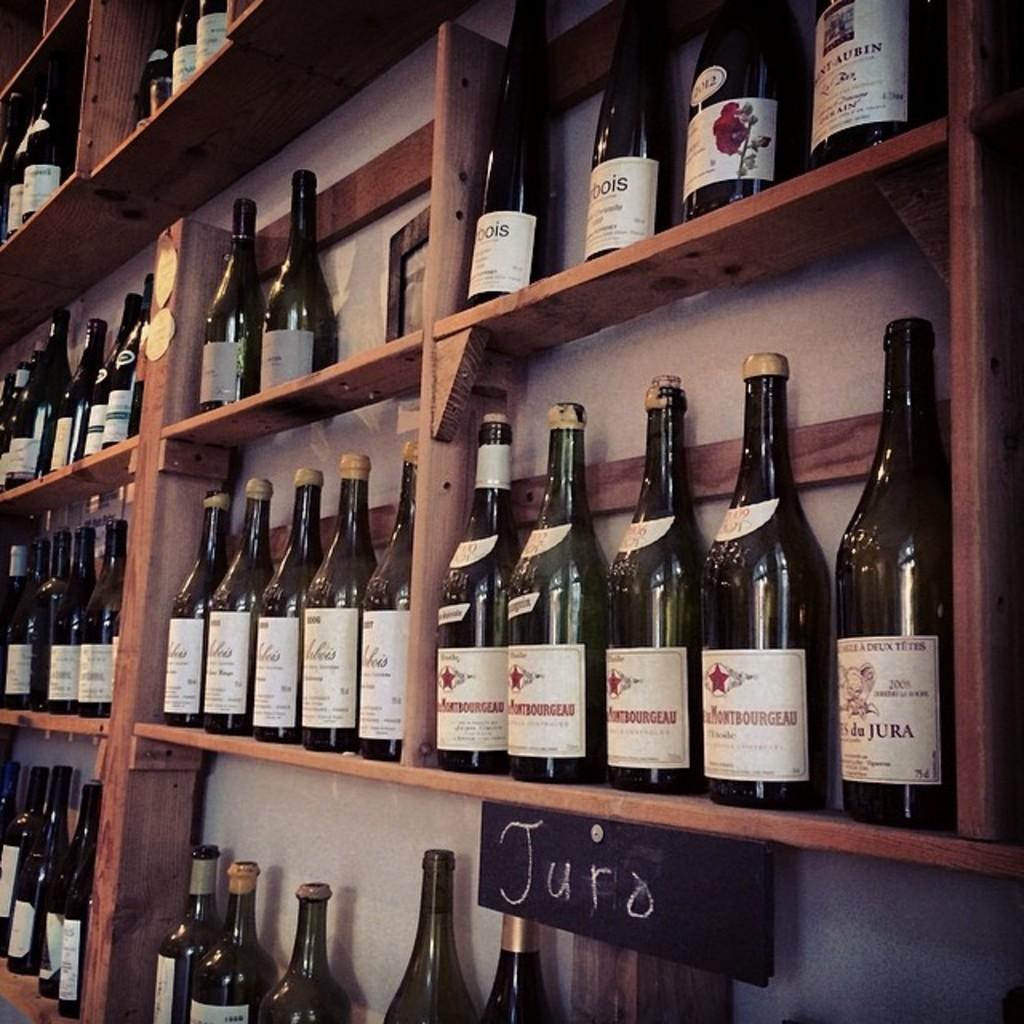What wine category is written on the board?
Keep it short and to the point. Juro. What word is visible on the wine closest to the camera?
Give a very brief answer. Juro. 